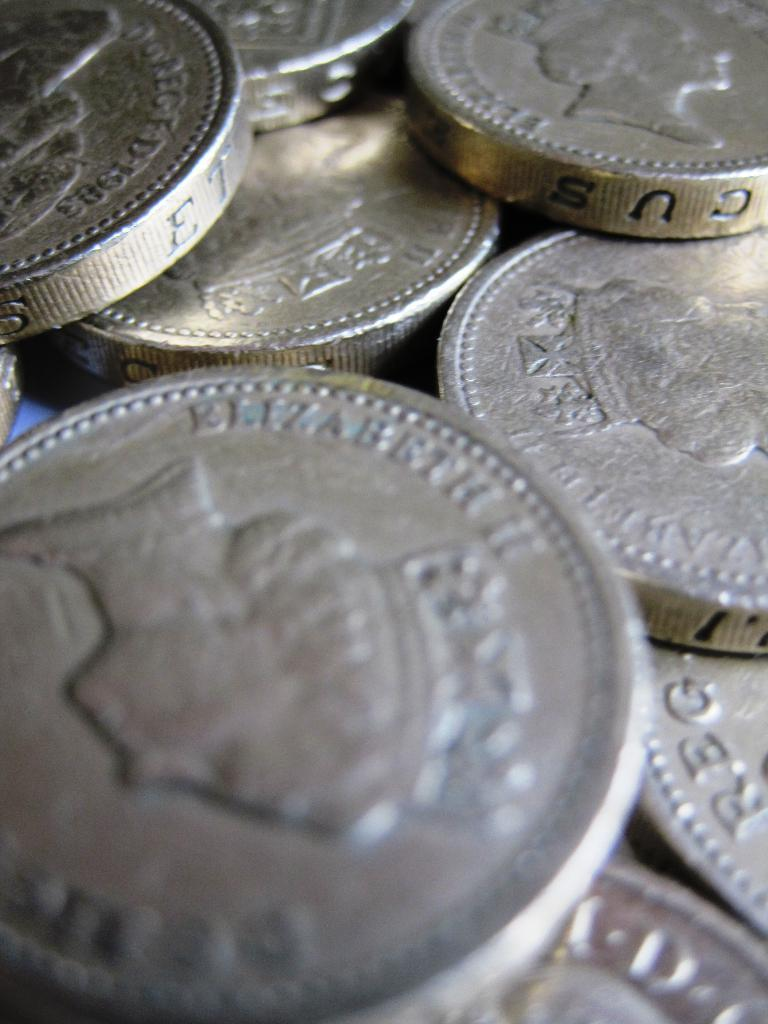<image>
Provide a brief description of the given image. A pile of Canadian Currency that has Queen Elizabeth II on it. 